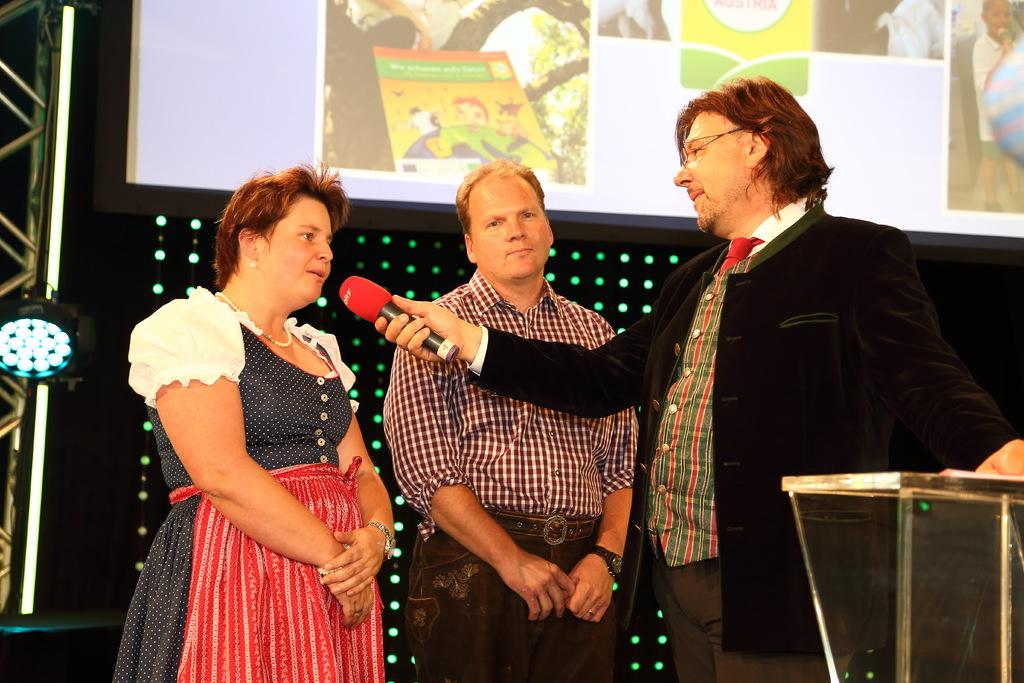How many people are in the image? There are two men and a woman standing in the image. What is one of the men holding? One man is holding a microphone. What object can be seen in the image that is often used for speeches or presentations? There is a podium in the image. Can you describe the possible lighting conditions in the image? There may be lights behind the people in the image. What is another object present in the image that might be used for displaying information or visuals? There is a screen in the image. How many cars can be seen driving through the fog in the image? There are no cars or fog present in the image. What is the digestive process of the woman in the image? The image does not provide any information about the woman's digestive process. 